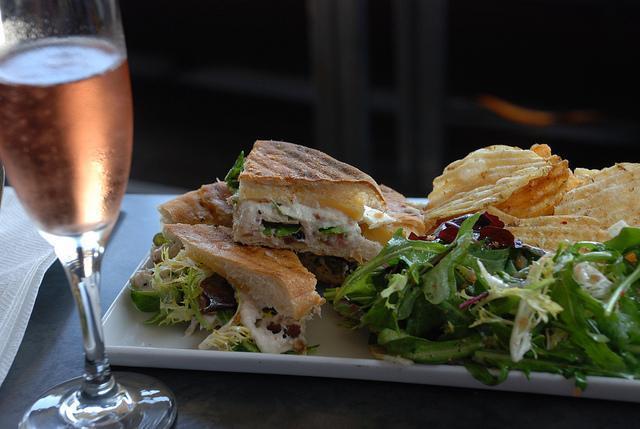How many sandwiches are there?
Give a very brief answer. 2. 